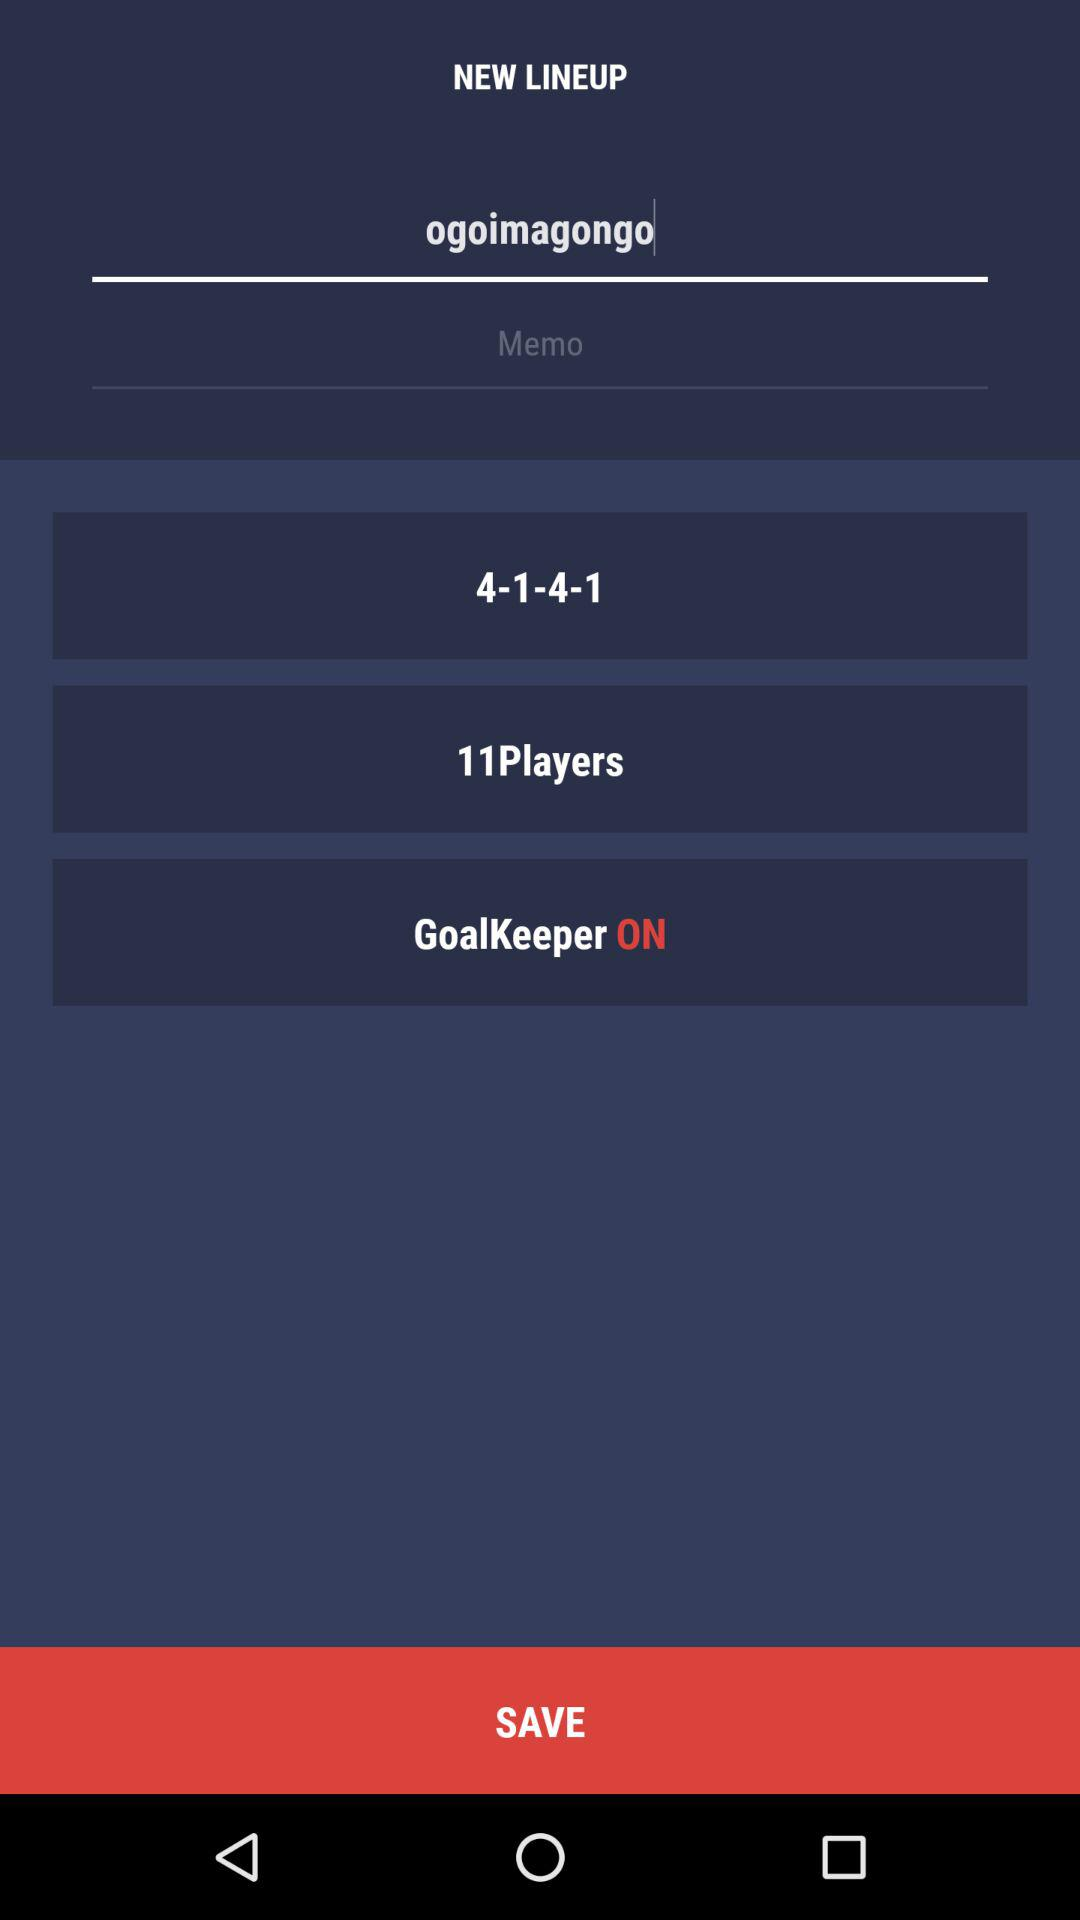What are the mentioned scores? The mentioned scores are 4-1-4-1. 